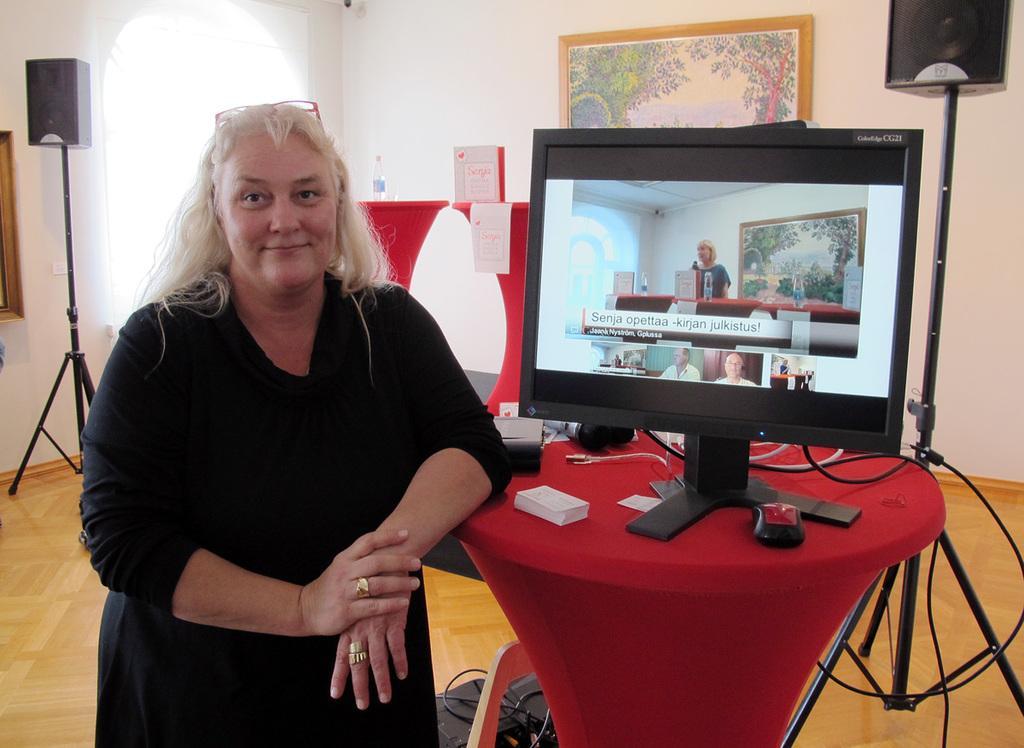Please provide a concise description of this image. This is the picture of a room. In this image there is a woman standing and smiling. There is a computer, mouse and there are devices on the table. At the back there is a board and there is a bottle on the tables. There are frames on the wall and there are speakers. At the bottom there is a device on the wooden floor. 